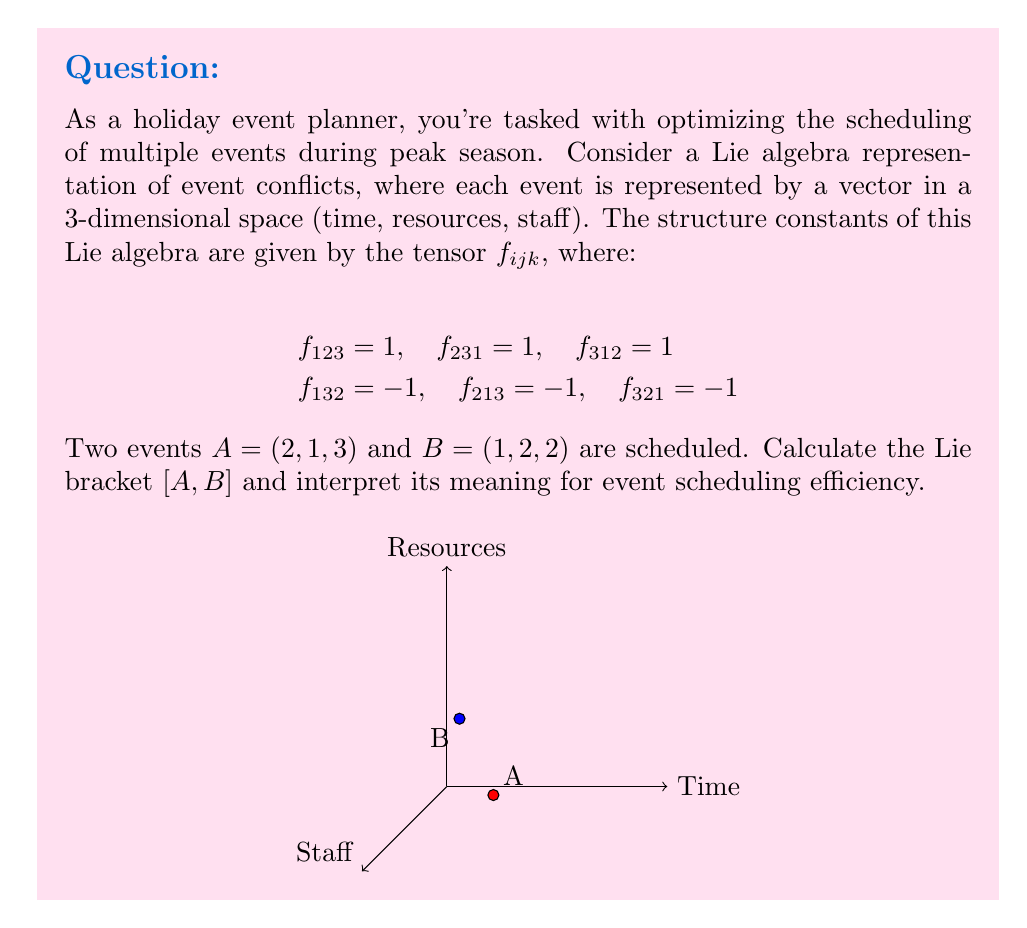Can you solve this math problem? Let's approach this step-by-step:

1) The Lie bracket $[A, B]$ is defined as:

   $$[A, B]^k = \sum_{i,j} f_{ij}^k A^i B^j$$

   where $A^i$ and $B^j$ are the components of vectors $A$ and $B$, respectively.

2) We need to calculate each component of $[A, B]$:

   For $k = 1$ (Time component):
   $$[A, B]^1 = f_{23}^1 A^2 B^3 + f_{32}^1 A^3 B^2 = (1)(1)(2) + (-1)(3)(2) = 2 - 6 = -4$$

   For $k = 2$ (Resources component):
   $$[A, B]^2 = f_{31}^2 A^3 B^1 + f_{13}^2 A^1 B^3 = (1)(3)(1) + (-1)(2)(2) = 3 - 4 = -1$$

   For $k = 3$ (Staff component):
   $$[A, B]^3 = f_{12}^3 A^1 B^2 + f_{21}^3 A^2 B^1 = (1)(2)(2) + (-1)(1)(1) = 4 - 1 = 3$$

3) Therefore, the Lie bracket $[A, B] = (-4, -1, 3)$.

4) Interpretation:
   - The negative time component (-4) suggests that scheduling these events together creates time conflicts.
   - The negative resources component (-1) indicates a slight resource conflict.
   - The positive staff component (3) suggests that there might be an excess of staff when these events are scheduled together.

This result indicates that the current scheduling of events A and B is not efficient, particularly in terms of time management and resource allocation.
Answer: $[A, B] = (-4, -1, 3)$, indicating scheduling inefficiency. 